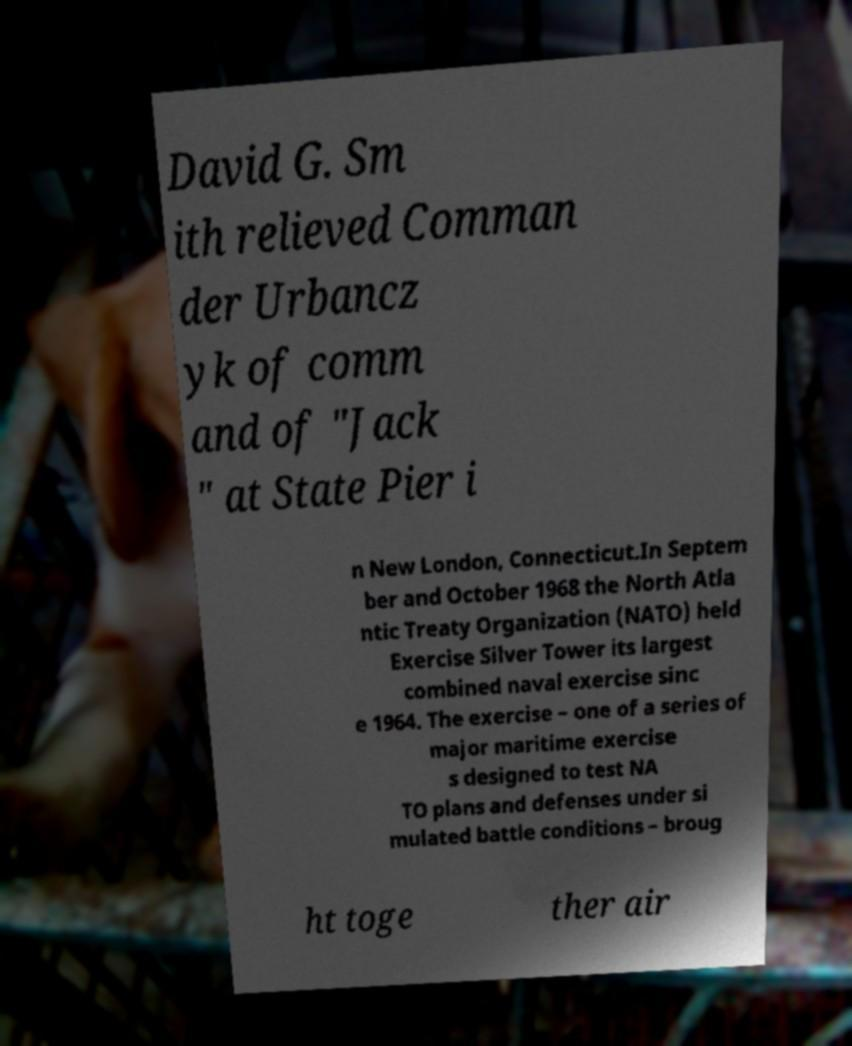Please read and relay the text visible in this image. What does it say? David G. Sm ith relieved Comman der Urbancz yk of comm and of "Jack " at State Pier i n New London, Connecticut.In Septem ber and October 1968 the North Atla ntic Treaty Organization (NATO) held Exercise Silver Tower its largest combined naval exercise sinc e 1964. The exercise – one of a series of major maritime exercise s designed to test NA TO plans and defenses under si mulated battle conditions – broug ht toge ther air 